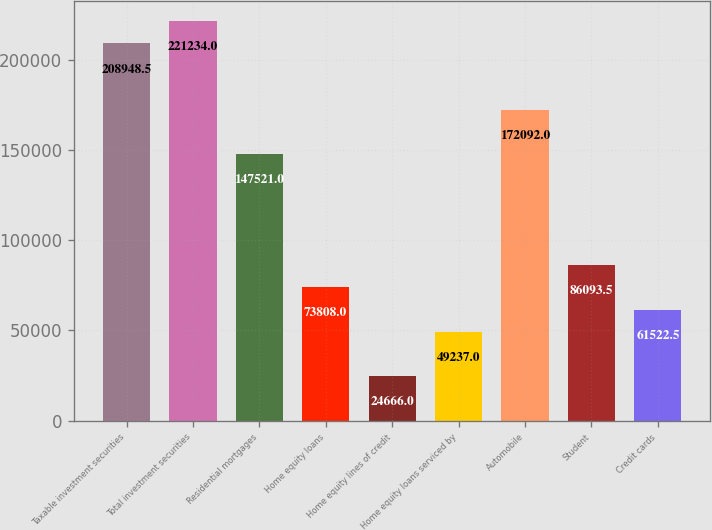Convert chart. <chart><loc_0><loc_0><loc_500><loc_500><bar_chart><fcel>Taxable investment securities<fcel>Total investment securities<fcel>Residential mortgages<fcel>Home equity loans<fcel>Home equity lines of credit<fcel>Home equity loans serviced by<fcel>Automobile<fcel>Student<fcel>Credit cards<nl><fcel>208948<fcel>221234<fcel>147521<fcel>73808<fcel>24666<fcel>49237<fcel>172092<fcel>86093.5<fcel>61522.5<nl></chart> 